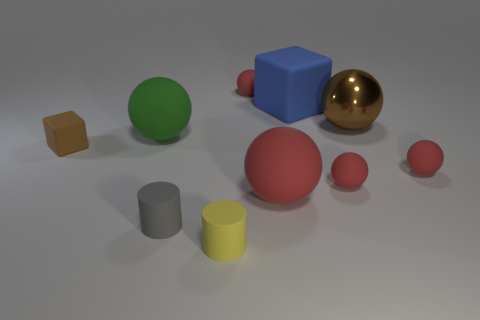If this image were part of an advertisement, what could it be promoting? If this image were used in an advertisement, it could promote a variety of concepts. Given the clean and simple setup, it might be advertising the importance of simplicity and organization in design spaces. It could also be interpreted as promoting educational toys focused on teaching children about shapes and colors, or it might be a visual representation of a computer graphics program demonstrating its rendering capabilities of inanimate objects with different textures and materials. 